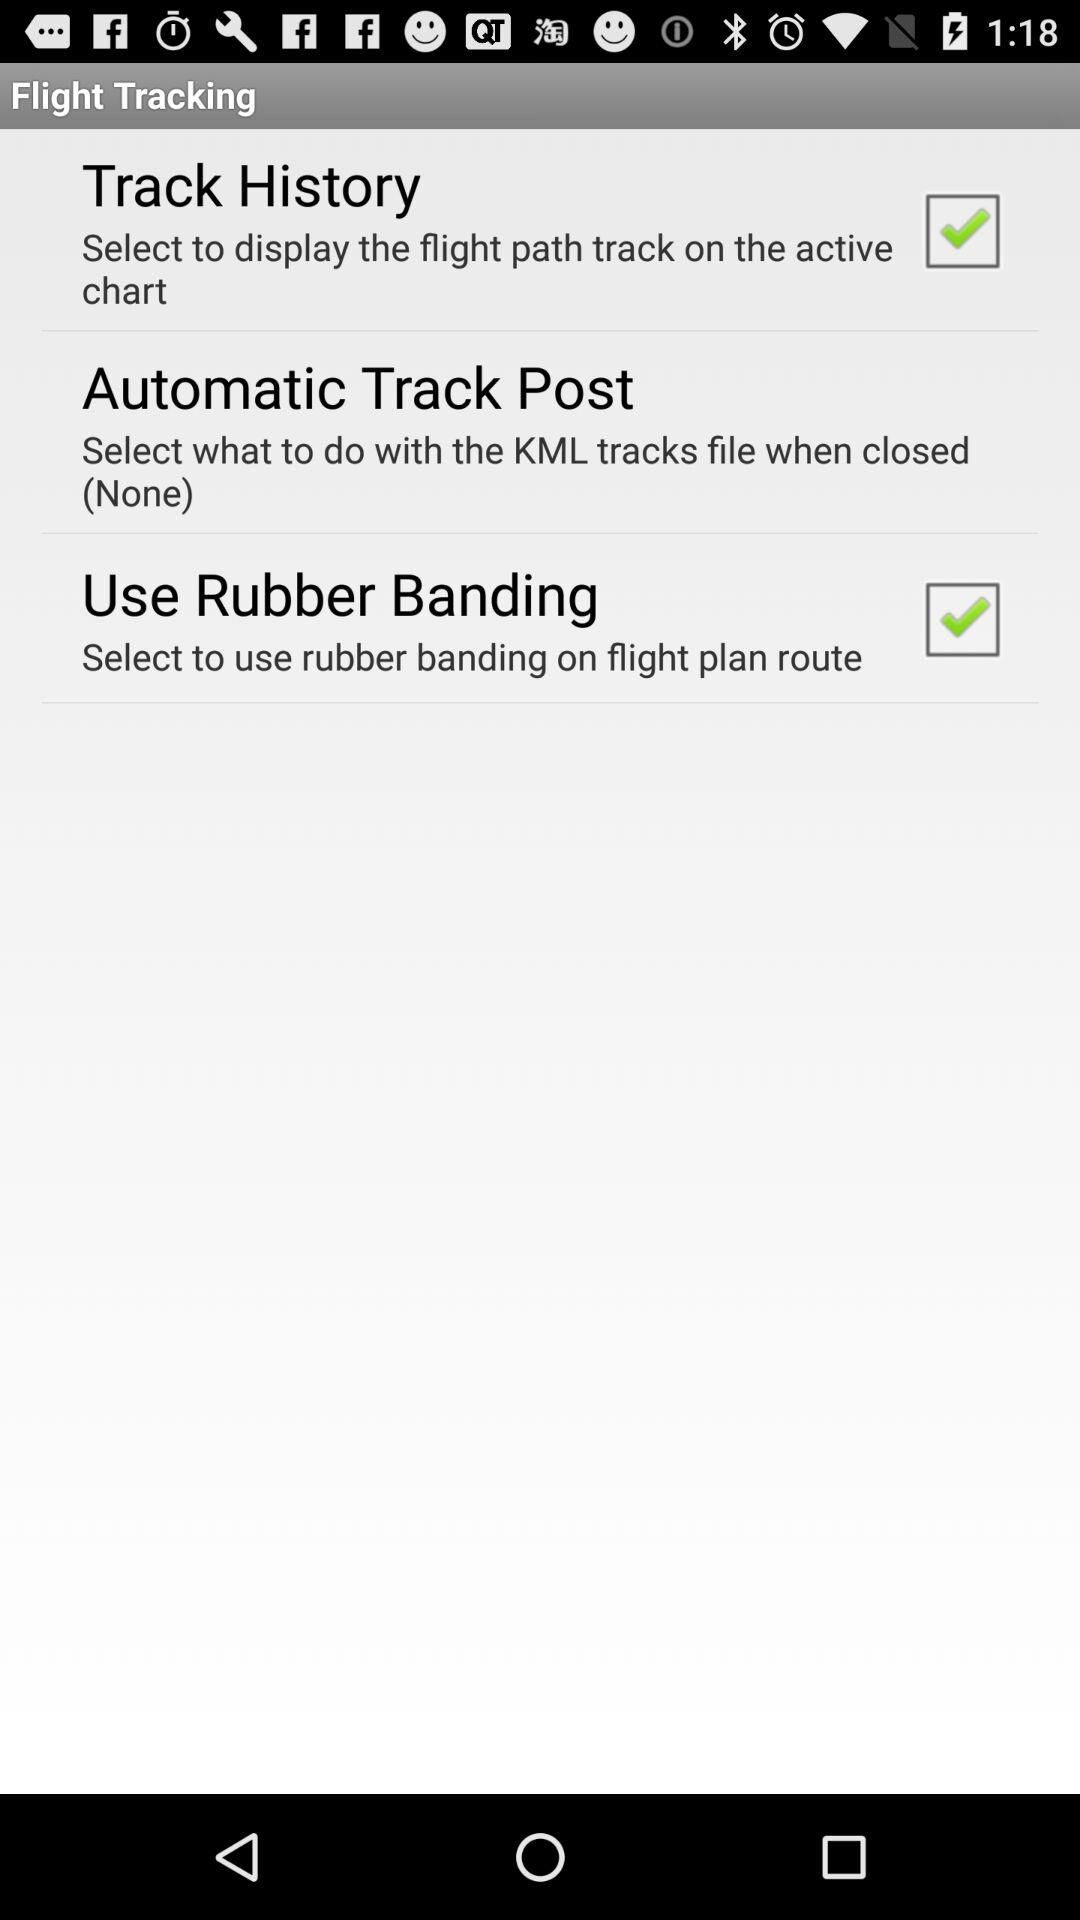What is the status of "Use Rubber Banding"? The status of "Use Rubber Banding" is "on". 